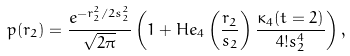Convert formula to latex. <formula><loc_0><loc_0><loc_500><loc_500>p ( r _ { 2 } ) = \frac { e ^ { - r _ { 2 } ^ { 2 } / 2 s _ { 2 } ^ { 2 } } } { \sqrt { 2 \pi } } \left ( 1 + H e _ { 4 } \left ( \frac { r _ { 2 } } { s _ { 2 } } \right ) \frac { \kappa _ { 4 } ( t = 2 ) } { 4 ! s _ { 2 } ^ { 4 } } \right ) ,</formula> 